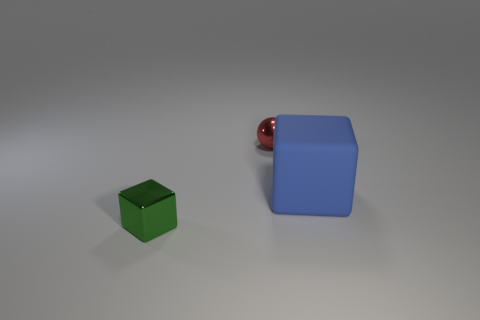How many large objects are blue cubes or yellow metal cylinders?
Ensure brevity in your answer.  1. Is there a purple rubber block of the same size as the green metallic object?
Keep it short and to the point. No. The small shiny object that is behind the block that is right of the red thing that is behind the large thing is what color?
Keep it short and to the point. Red. Is the material of the red object the same as the cube that is behind the metallic cube?
Offer a terse response. No. There is a blue matte object that is the same shape as the tiny green object; what is its size?
Offer a terse response. Large. Are there the same number of small objects that are in front of the green shiny block and blocks that are in front of the big object?
Your answer should be very brief. No. How many other objects are there of the same material as the large block?
Offer a very short reply. 0. Is the number of balls behind the metal cube the same as the number of small green cubes?
Keep it short and to the point. Yes. Do the red ball and the cube in front of the big cube have the same size?
Make the answer very short. Yes. There is a tiny object behind the large blue block; what is its shape?
Your response must be concise. Sphere. 